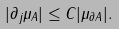Convert formula to latex. <formula><loc_0><loc_0><loc_500><loc_500>| \partial _ { j } \mu _ { A } | \leq C | \mu _ { \partial A } | .</formula> 